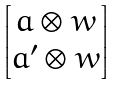<formula> <loc_0><loc_0><loc_500><loc_500>\begin{bmatrix} a \otimes w \\ a ^ { \prime } \otimes w \end{bmatrix}</formula> 